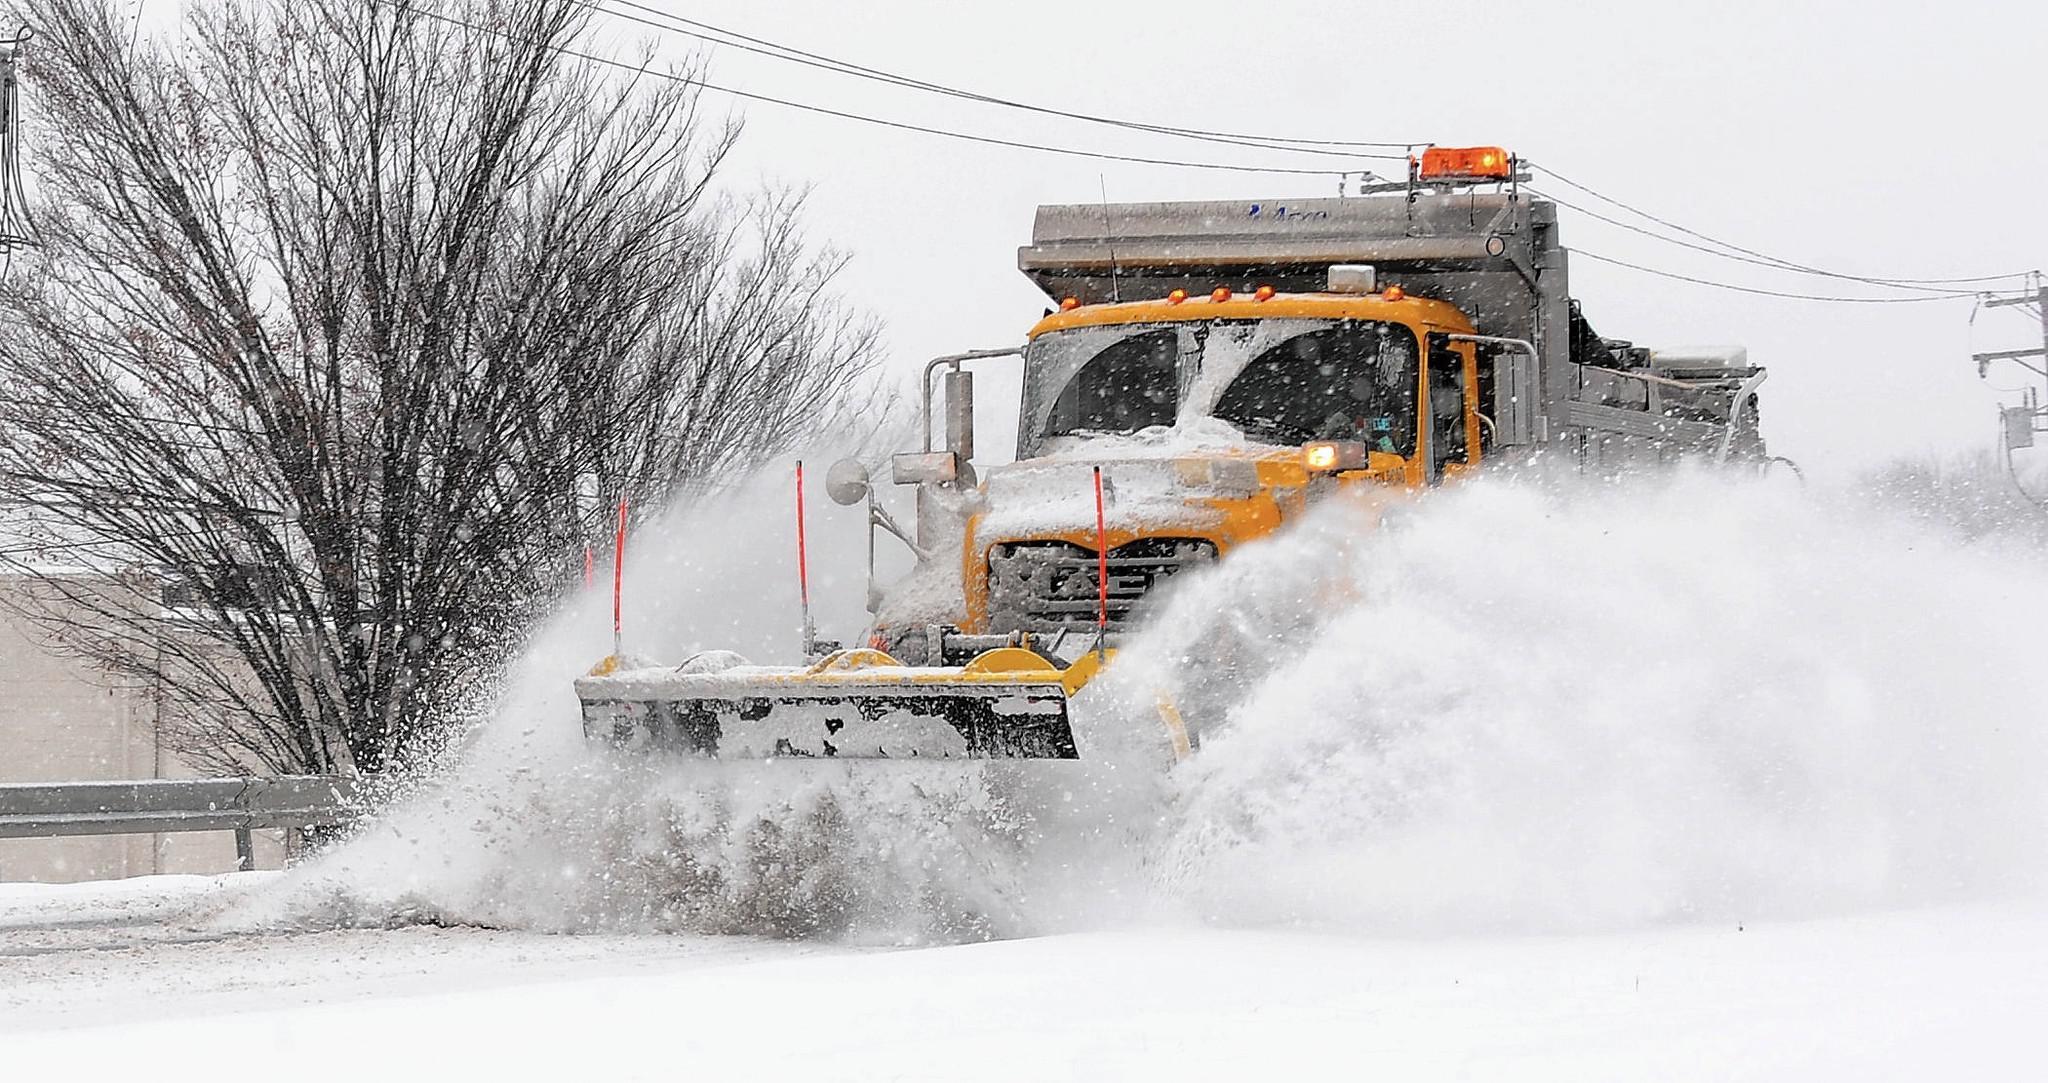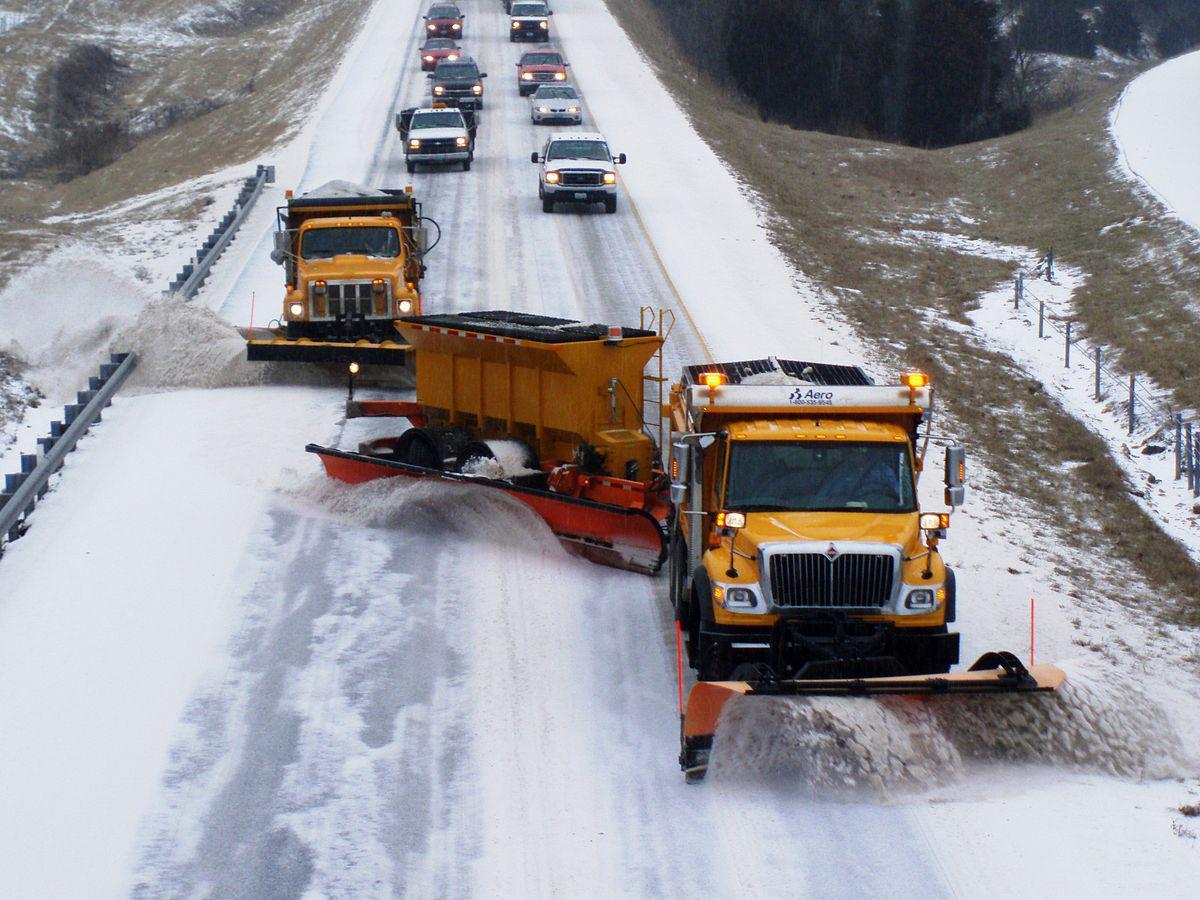The first image is the image on the left, the second image is the image on the right. Considering the images on both sides, is "In one of the images, the snow plow is not pushing snow." valid? Answer yes or no. No. 